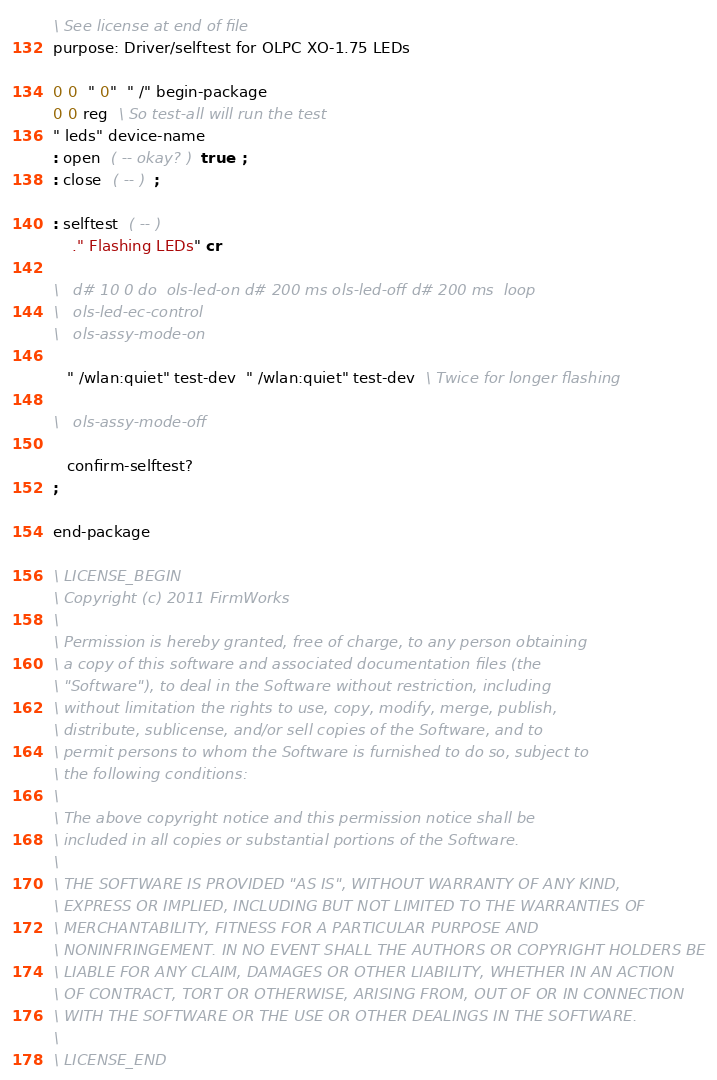<code> <loc_0><loc_0><loc_500><loc_500><_Forth_>\ See license at end of file
purpose: Driver/selftest for OLPC XO-1.75 LEDs

0 0  " 0"  " /" begin-package
0 0 reg  \ So test-all will run the test
" leds" device-name
: open  ( -- okay? )  true  ;
: close  ( -- )  ;

: selftest  ( -- )
    ." Flashing LEDs" cr

\   d# 10 0 do  ols-led-on d# 200 ms ols-led-off d# 200 ms  loop
\   ols-led-ec-control
\   ols-assy-mode-on

   " /wlan:quiet" test-dev  " /wlan:quiet" test-dev  \ Twice for longer flashing

\   ols-assy-mode-off

   confirm-selftest?
;

end-package

\ LICENSE_BEGIN
\ Copyright (c) 2011 FirmWorks
\ 
\ Permission is hereby granted, free of charge, to any person obtaining
\ a copy of this software and associated documentation files (the
\ "Software"), to deal in the Software without restriction, including
\ without limitation the rights to use, copy, modify, merge, publish,
\ distribute, sublicense, and/or sell copies of the Software, and to
\ permit persons to whom the Software is furnished to do so, subject to
\ the following conditions:
\ 
\ The above copyright notice and this permission notice shall be
\ included in all copies or substantial portions of the Software.
\ 
\ THE SOFTWARE IS PROVIDED "AS IS", WITHOUT WARRANTY OF ANY KIND,
\ EXPRESS OR IMPLIED, INCLUDING BUT NOT LIMITED TO THE WARRANTIES OF
\ MERCHANTABILITY, FITNESS FOR A PARTICULAR PURPOSE AND
\ NONINFRINGEMENT. IN NO EVENT SHALL THE AUTHORS OR COPYRIGHT HOLDERS BE
\ LIABLE FOR ANY CLAIM, DAMAGES OR OTHER LIABILITY, WHETHER IN AN ACTION
\ OF CONTRACT, TORT OR OTHERWISE, ARISING FROM, OUT OF OR IN CONNECTION
\ WITH THE SOFTWARE OR THE USE OR OTHER DEALINGS IN THE SOFTWARE.
\
\ LICENSE_END
</code> 